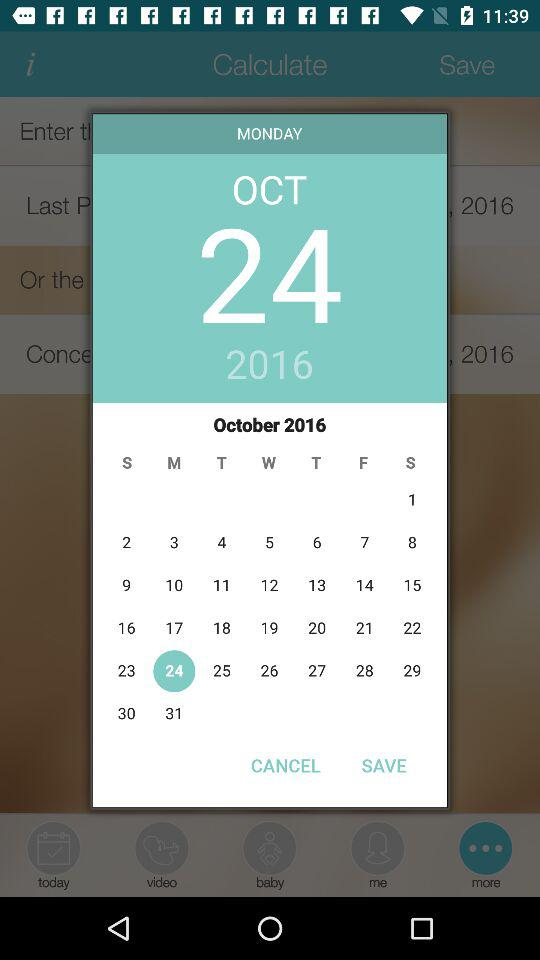What is the selected date? The selected date is October 24, 2017. 